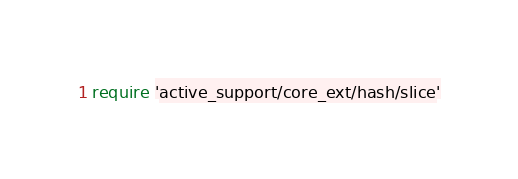<code> <loc_0><loc_0><loc_500><loc_500><_Ruby_>require 'active_support/core_ext/hash/slice'</code> 